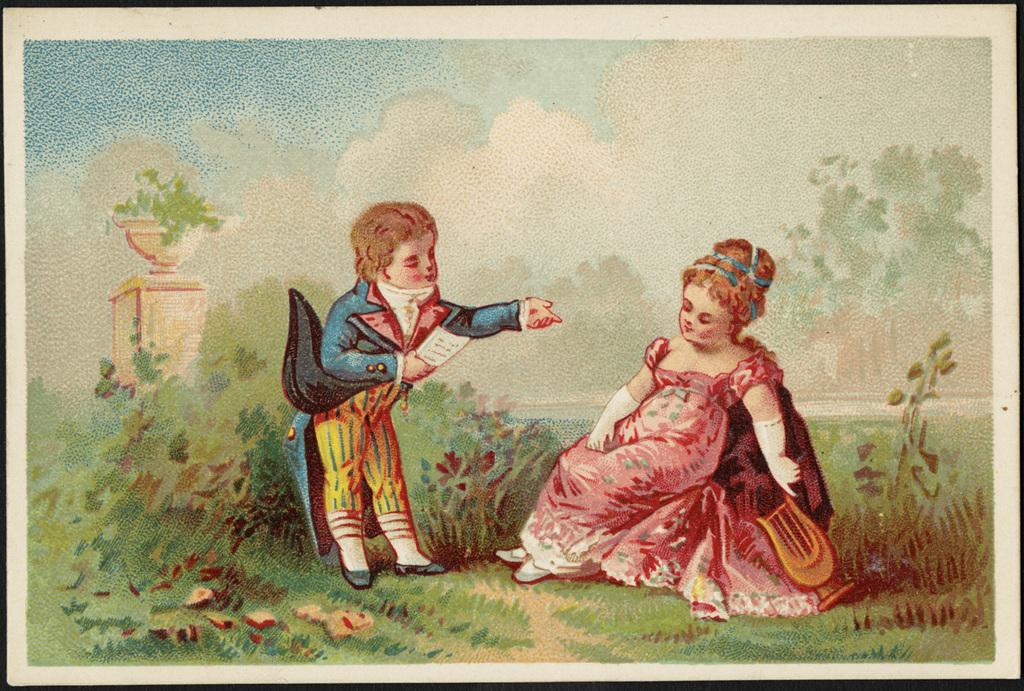What is the main subject of the image? The main subjects of the image are a little boy and a little girl. What is the little boy doing in the image? The little boy is standing in the image. What is the little girl doing in the image? The little girl is sitting in the image. What is the little girl wearing in the image? The little girl is wearing a pink dress in the image. What can be seen on the right side of the image? There are trees on the right side of the image. What type of comb is the little boy using to style his hair in the image? There is no comb visible in the image, and the little boy's hair is not being styled. 